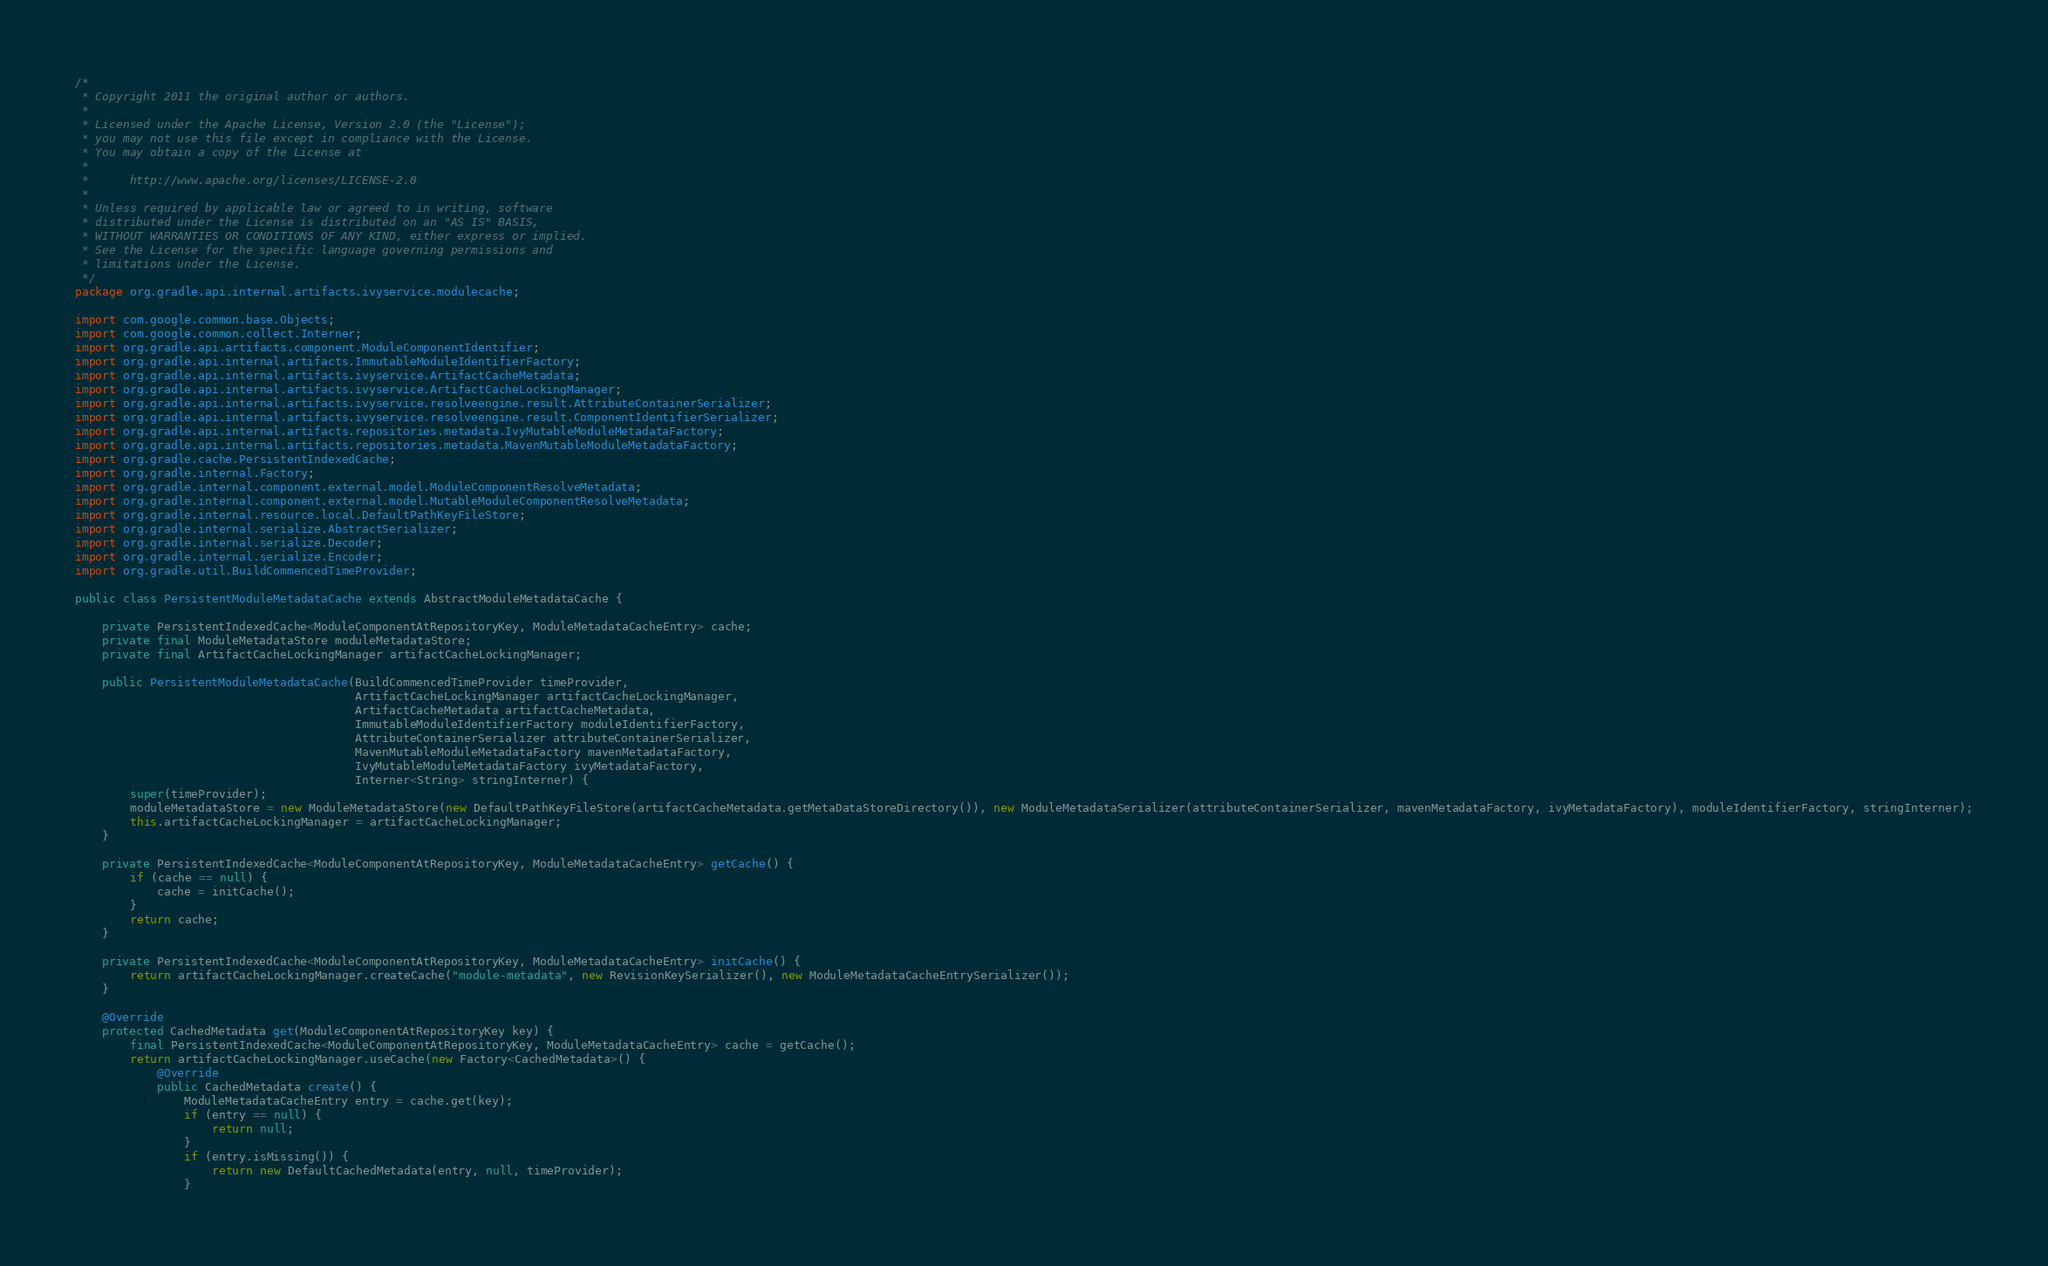Convert code to text. <code><loc_0><loc_0><loc_500><loc_500><_Java_>/*
 * Copyright 2011 the original author or authors.
 *
 * Licensed under the Apache License, Version 2.0 (the "License");
 * you may not use this file except in compliance with the License.
 * You may obtain a copy of the License at
 *
 *      http://www.apache.org/licenses/LICENSE-2.0
 *
 * Unless required by applicable law or agreed to in writing, software
 * distributed under the License is distributed on an "AS IS" BASIS,
 * WITHOUT WARRANTIES OR CONDITIONS OF ANY KIND, either express or implied.
 * See the License for the specific language governing permissions and
 * limitations under the License.
 */
package org.gradle.api.internal.artifacts.ivyservice.modulecache;

import com.google.common.base.Objects;
import com.google.common.collect.Interner;
import org.gradle.api.artifacts.component.ModuleComponentIdentifier;
import org.gradle.api.internal.artifacts.ImmutableModuleIdentifierFactory;
import org.gradle.api.internal.artifacts.ivyservice.ArtifactCacheMetadata;
import org.gradle.api.internal.artifacts.ivyservice.ArtifactCacheLockingManager;
import org.gradle.api.internal.artifacts.ivyservice.resolveengine.result.AttributeContainerSerializer;
import org.gradle.api.internal.artifacts.ivyservice.resolveengine.result.ComponentIdentifierSerializer;
import org.gradle.api.internal.artifacts.repositories.metadata.IvyMutableModuleMetadataFactory;
import org.gradle.api.internal.artifacts.repositories.metadata.MavenMutableModuleMetadataFactory;
import org.gradle.cache.PersistentIndexedCache;
import org.gradle.internal.Factory;
import org.gradle.internal.component.external.model.ModuleComponentResolveMetadata;
import org.gradle.internal.component.external.model.MutableModuleComponentResolveMetadata;
import org.gradle.internal.resource.local.DefaultPathKeyFileStore;
import org.gradle.internal.serialize.AbstractSerializer;
import org.gradle.internal.serialize.Decoder;
import org.gradle.internal.serialize.Encoder;
import org.gradle.util.BuildCommencedTimeProvider;

public class PersistentModuleMetadataCache extends AbstractModuleMetadataCache {

    private PersistentIndexedCache<ModuleComponentAtRepositoryKey, ModuleMetadataCacheEntry> cache;
    private final ModuleMetadataStore moduleMetadataStore;
    private final ArtifactCacheLockingManager artifactCacheLockingManager;

    public PersistentModuleMetadataCache(BuildCommencedTimeProvider timeProvider,
                                         ArtifactCacheLockingManager artifactCacheLockingManager,
                                         ArtifactCacheMetadata artifactCacheMetadata,
                                         ImmutableModuleIdentifierFactory moduleIdentifierFactory,
                                         AttributeContainerSerializer attributeContainerSerializer,
                                         MavenMutableModuleMetadataFactory mavenMetadataFactory,
                                         IvyMutableModuleMetadataFactory ivyMetadataFactory,
                                         Interner<String> stringInterner) {
        super(timeProvider);
        moduleMetadataStore = new ModuleMetadataStore(new DefaultPathKeyFileStore(artifactCacheMetadata.getMetaDataStoreDirectory()), new ModuleMetadataSerializer(attributeContainerSerializer, mavenMetadataFactory, ivyMetadataFactory), moduleIdentifierFactory, stringInterner);
        this.artifactCacheLockingManager = artifactCacheLockingManager;
    }

    private PersistentIndexedCache<ModuleComponentAtRepositoryKey, ModuleMetadataCacheEntry> getCache() {
        if (cache == null) {
            cache = initCache();
        }
        return cache;
    }

    private PersistentIndexedCache<ModuleComponentAtRepositoryKey, ModuleMetadataCacheEntry> initCache() {
        return artifactCacheLockingManager.createCache("module-metadata", new RevisionKeySerializer(), new ModuleMetadataCacheEntrySerializer());
    }

    @Override
    protected CachedMetadata get(ModuleComponentAtRepositoryKey key) {
        final PersistentIndexedCache<ModuleComponentAtRepositoryKey, ModuleMetadataCacheEntry> cache = getCache();
        return artifactCacheLockingManager.useCache(new Factory<CachedMetadata>() {
            @Override
            public CachedMetadata create() {
                ModuleMetadataCacheEntry entry = cache.get(key);
                if (entry == null) {
                    return null;
                }
                if (entry.isMissing()) {
                    return new DefaultCachedMetadata(entry, null, timeProvider);
                }</code> 